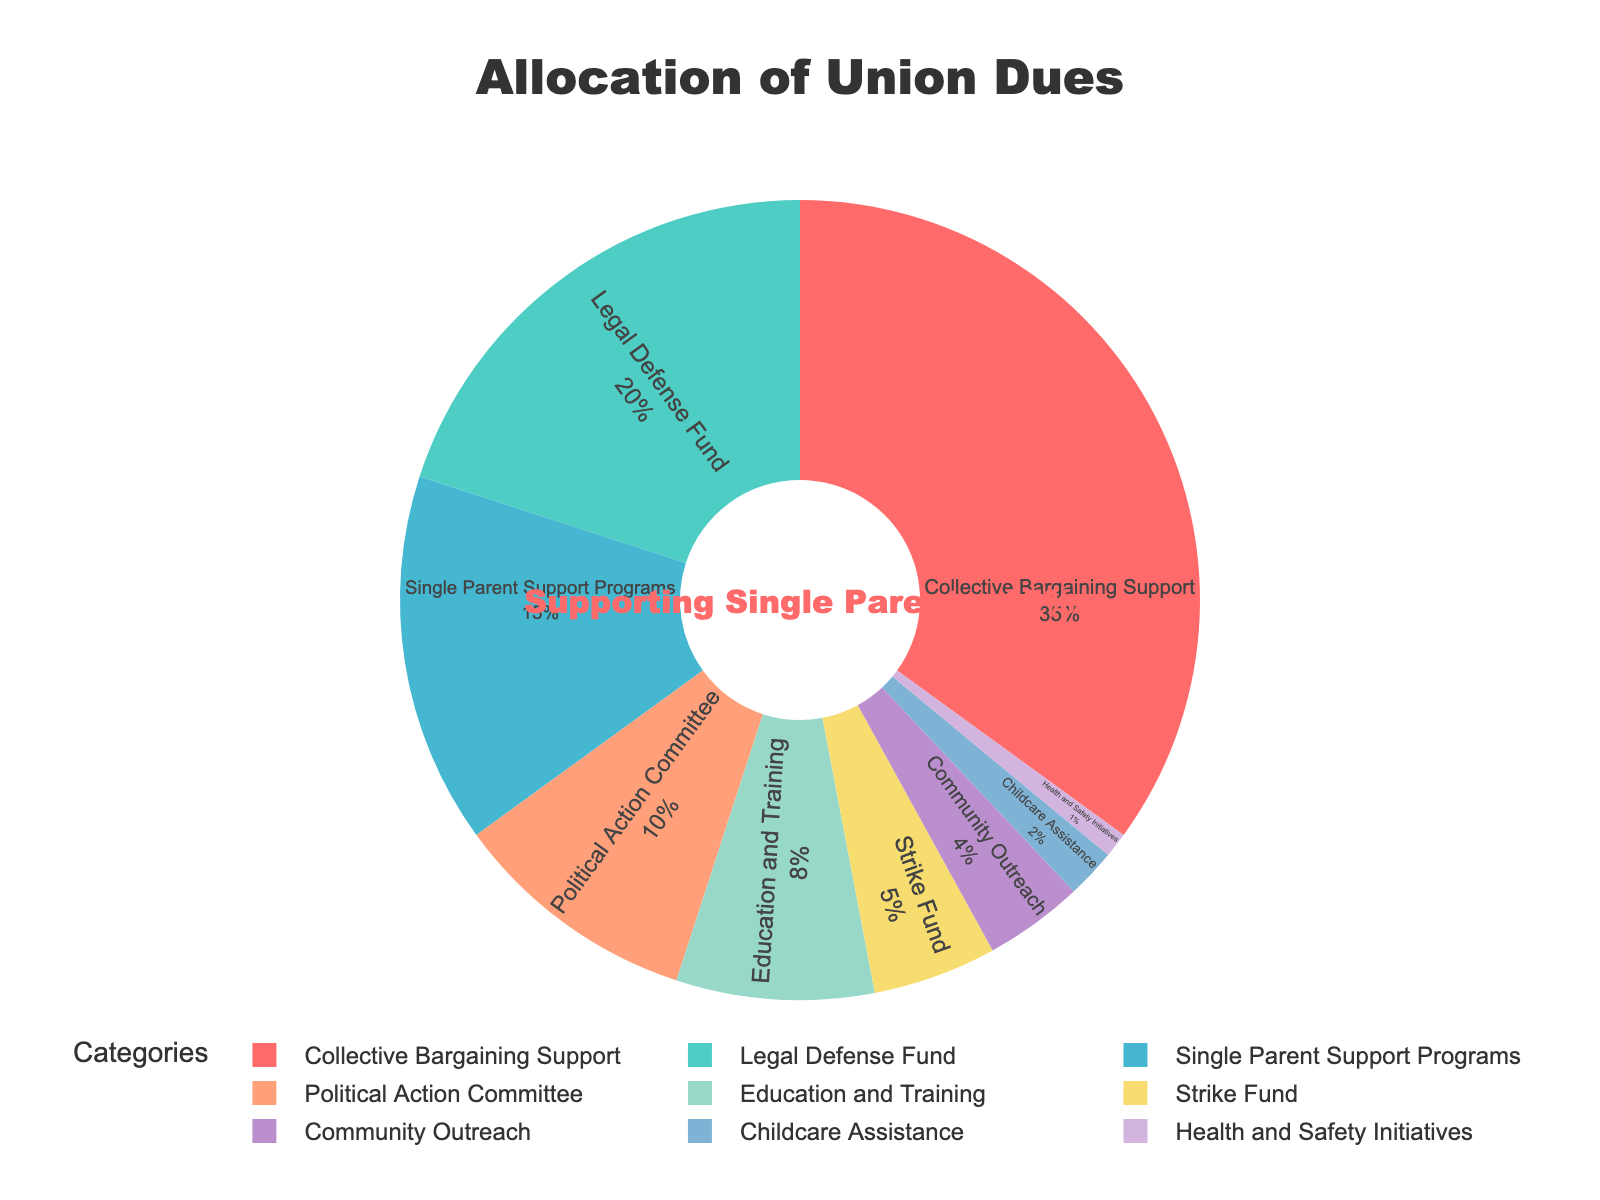What percentage of union dues is allocated to the Strike Fund? To determine the percentage of union dues allocated to the Strike Fund, refer to the section labeled "Strike Fund" in the pie chart. The percentage value associated with this section is indicated.
Answer: 5% Which category receives more funding, Education and Training or Community Outreach? Compare the values assigned to "Education and Training" and "Community Outreach" in the pie chart. Education and Training is allocated 8%, while Community Outreach receives 4%. Since 8% is greater than 4%, "Education and Training" receives more funding.
Answer: Education and Training How much more is allocated to Collective Bargaining Support compared to the Single Parent Support Programs? The percentage allocated to Collective Bargaining Support is 35%, while Single Parent Support Programs receive 15%. Subtract 15% from 35% to find the difference.
Answer: 20% What is the sum of the percentages allocated to Legal Defense Fund, Political Action Committee, and Childcare Assistance? Add the percentages of the Legal Defense Fund (20%), Political Action Committee (10%), and Childcare Assistance (2%). Sum these values: 20 + 10 + 2 = 32%.
Answer: 32% Which category is represented by the color red in the pie chart? Identify the section of the pie chart that is colored red. The red color is used to highlight the annotation which specifies "Supporting Single Parents: 15%".
Answer: Single Parent Support Programs Compare the allocation for Health and Safety Initiatives to that for Childcare Assistance. Which receives more? Health and Safety Initiatives are allocated 1%, while Childcare Assistance receives 2%. Since 2% is greater than 1%, Childcare Assistance receives more.
Answer: Childcare Assistance What is the total percentage allocated to Political Action Committee and Community Outreach combined? Add the percentages of the Political Action Committee (10%) and Community Outreach (4%). Sum these values: 10 + 4 = 14%.
Answer: 14% Is the percentage for Legal Defense Fund more, less, or equal to the combined percentage of Strike Fund and Health and Safety Initiatives? The Legal Defense Fund is allocated 20%. The combined percentage of the Strike Fund (5%) and Health and Safety Initiatives (1%) is 5 + 1 = 6%. Since 20% is greater than 6%, Legal Defense Fund receives more.
Answer: More What percentage of union dues is allocated to Education and Training, Community Outreach, and Health and Safety Initiatives combined? Add the percentages for Education and Training (8%), Community Outreach (4%), and Health and Safety Initiatives (1%). Sum these values: 8 + 4 + 1 = 13%.
Answer: 13% 